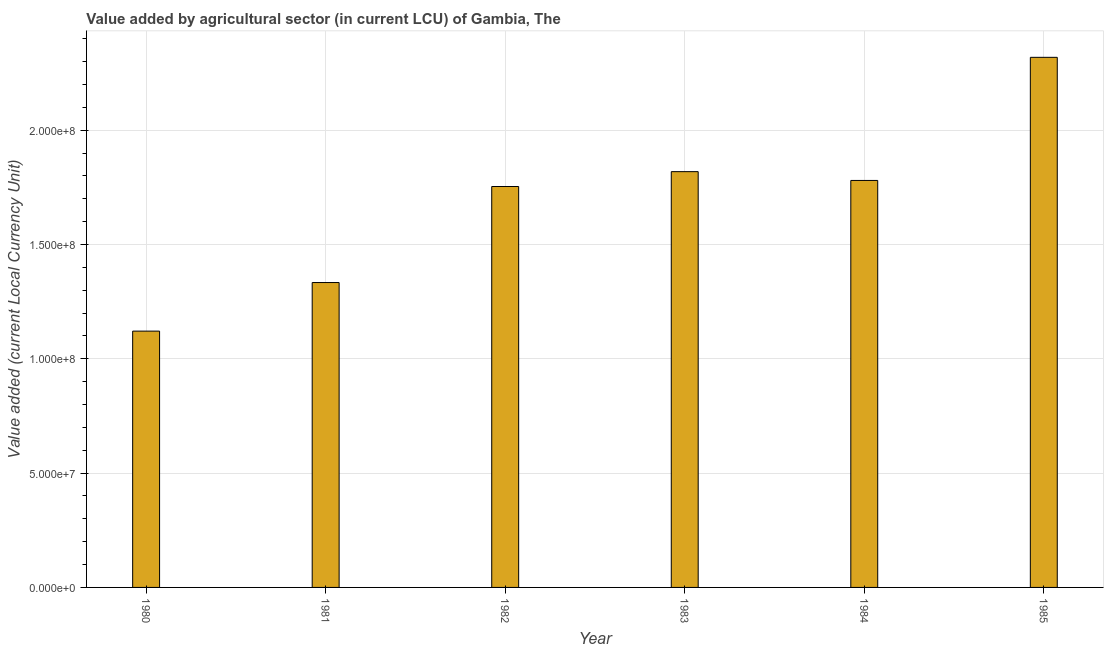What is the title of the graph?
Offer a terse response. Value added by agricultural sector (in current LCU) of Gambia, The. What is the label or title of the Y-axis?
Make the answer very short. Value added (current Local Currency Unit). What is the value added by agriculture sector in 1981?
Provide a succinct answer. 1.33e+08. Across all years, what is the maximum value added by agriculture sector?
Provide a short and direct response. 2.32e+08. Across all years, what is the minimum value added by agriculture sector?
Your answer should be compact. 1.12e+08. In which year was the value added by agriculture sector maximum?
Offer a terse response. 1985. What is the sum of the value added by agriculture sector?
Ensure brevity in your answer.  1.01e+09. What is the difference between the value added by agriculture sector in 1980 and 1984?
Give a very brief answer. -6.59e+07. What is the average value added by agriculture sector per year?
Your answer should be compact. 1.69e+08. What is the median value added by agriculture sector?
Give a very brief answer. 1.77e+08. What is the ratio of the value added by agriculture sector in 1981 to that in 1985?
Offer a terse response. 0.57. Is the difference between the value added by agriculture sector in 1982 and 1985 greater than the difference between any two years?
Ensure brevity in your answer.  No. What is the difference between the highest and the lowest value added by agriculture sector?
Offer a very short reply. 1.20e+08. In how many years, is the value added by agriculture sector greater than the average value added by agriculture sector taken over all years?
Your answer should be very brief. 4. How many bars are there?
Provide a succinct answer. 6. How many years are there in the graph?
Offer a terse response. 6. What is the difference between two consecutive major ticks on the Y-axis?
Provide a short and direct response. 5.00e+07. Are the values on the major ticks of Y-axis written in scientific E-notation?
Offer a terse response. Yes. What is the Value added (current Local Currency Unit) of 1980?
Provide a short and direct response. 1.12e+08. What is the Value added (current Local Currency Unit) in 1981?
Offer a terse response. 1.33e+08. What is the Value added (current Local Currency Unit) of 1982?
Your response must be concise. 1.75e+08. What is the Value added (current Local Currency Unit) of 1983?
Your answer should be very brief. 1.82e+08. What is the Value added (current Local Currency Unit) in 1984?
Make the answer very short. 1.78e+08. What is the Value added (current Local Currency Unit) in 1985?
Your answer should be compact. 2.32e+08. What is the difference between the Value added (current Local Currency Unit) in 1980 and 1981?
Ensure brevity in your answer.  -2.12e+07. What is the difference between the Value added (current Local Currency Unit) in 1980 and 1982?
Give a very brief answer. -6.32e+07. What is the difference between the Value added (current Local Currency Unit) in 1980 and 1983?
Provide a short and direct response. -6.98e+07. What is the difference between the Value added (current Local Currency Unit) in 1980 and 1984?
Ensure brevity in your answer.  -6.59e+07. What is the difference between the Value added (current Local Currency Unit) in 1980 and 1985?
Offer a very short reply. -1.20e+08. What is the difference between the Value added (current Local Currency Unit) in 1981 and 1982?
Your response must be concise. -4.20e+07. What is the difference between the Value added (current Local Currency Unit) in 1981 and 1983?
Offer a very short reply. -4.85e+07. What is the difference between the Value added (current Local Currency Unit) in 1981 and 1984?
Give a very brief answer. -4.46e+07. What is the difference between the Value added (current Local Currency Unit) in 1981 and 1985?
Offer a very short reply. -9.85e+07. What is the difference between the Value added (current Local Currency Unit) in 1982 and 1983?
Offer a very short reply. -6.50e+06. What is the difference between the Value added (current Local Currency Unit) in 1982 and 1984?
Provide a succinct answer. -2.65e+06. What is the difference between the Value added (current Local Currency Unit) in 1982 and 1985?
Give a very brief answer. -5.65e+07. What is the difference between the Value added (current Local Currency Unit) in 1983 and 1984?
Make the answer very short. 3.85e+06. What is the difference between the Value added (current Local Currency Unit) in 1983 and 1985?
Provide a succinct answer. -5.00e+07. What is the difference between the Value added (current Local Currency Unit) in 1984 and 1985?
Ensure brevity in your answer.  -5.38e+07. What is the ratio of the Value added (current Local Currency Unit) in 1980 to that in 1981?
Your answer should be very brief. 0.84. What is the ratio of the Value added (current Local Currency Unit) in 1980 to that in 1982?
Offer a terse response. 0.64. What is the ratio of the Value added (current Local Currency Unit) in 1980 to that in 1983?
Keep it short and to the point. 0.62. What is the ratio of the Value added (current Local Currency Unit) in 1980 to that in 1984?
Offer a very short reply. 0.63. What is the ratio of the Value added (current Local Currency Unit) in 1980 to that in 1985?
Offer a very short reply. 0.48. What is the ratio of the Value added (current Local Currency Unit) in 1981 to that in 1982?
Your answer should be very brief. 0.76. What is the ratio of the Value added (current Local Currency Unit) in 1981 to that in 1983?
Your answer should be very brief. 0.73. What is the ratio of the Value added (current Local Currency Unit) in 1981 to that in 1984?
Your answer should be compact. 0.75. What is the ratio of the Value added (current Local Currency Unit) in 1981 to that in 1985?
Give a very brief answer. 0.57. What is the ratio of the Value added (current Local Currency Unit) in 1982 to that in 1985?
Offer a very short reply. 0.76. What is the ratio of the Value added (current Local Currency Unit) in 1983 to that in 1984?
Your response must be concise. 1.02. What is the ratio of the Value added (current Local Currency Unit) in 1983 to that in 1985?
Ensure brevity in your answer.  0.78. What is the ratio of the Value added (current Local Currency Unit) in 1984 to that in 1985?
Your answer should be very brief. 0.77. 